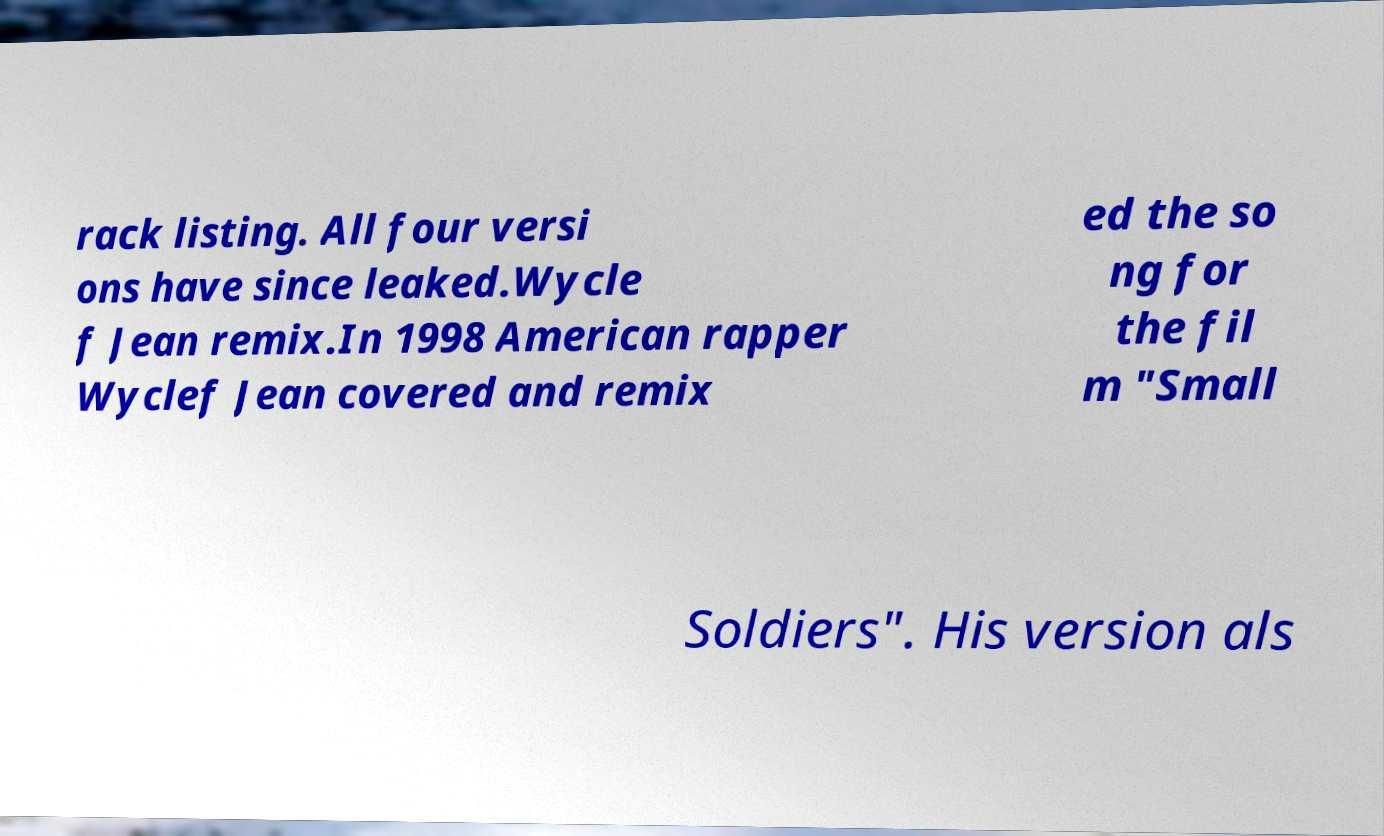Can you accurately transcribe the text from the provided image for me? rack listing. All four versi ons have since leaked.Wycle f Jean remix.In 1998 American rapper Wyclef Jean covered and remix ed the so ng for the fil m "Small Soldiers". His version als 